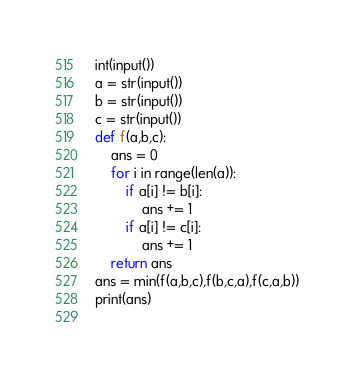Convert code to text. <code><loc_0><loc_0><loc_500><loc_500><_Python_>int(input())
a = str(input())
b = str(input())
c = str(input())
def f(a,b,c):
    ans = 0
    for i in range(len(a)):
        if a[i] != b[i]:
            ans += 1
        if a[i] != c[i]:
            ans += 1
    return ans
ans = min(f(a,b,c),f(b,c,a),f(c,a,b))
print(ans)
 </code> 